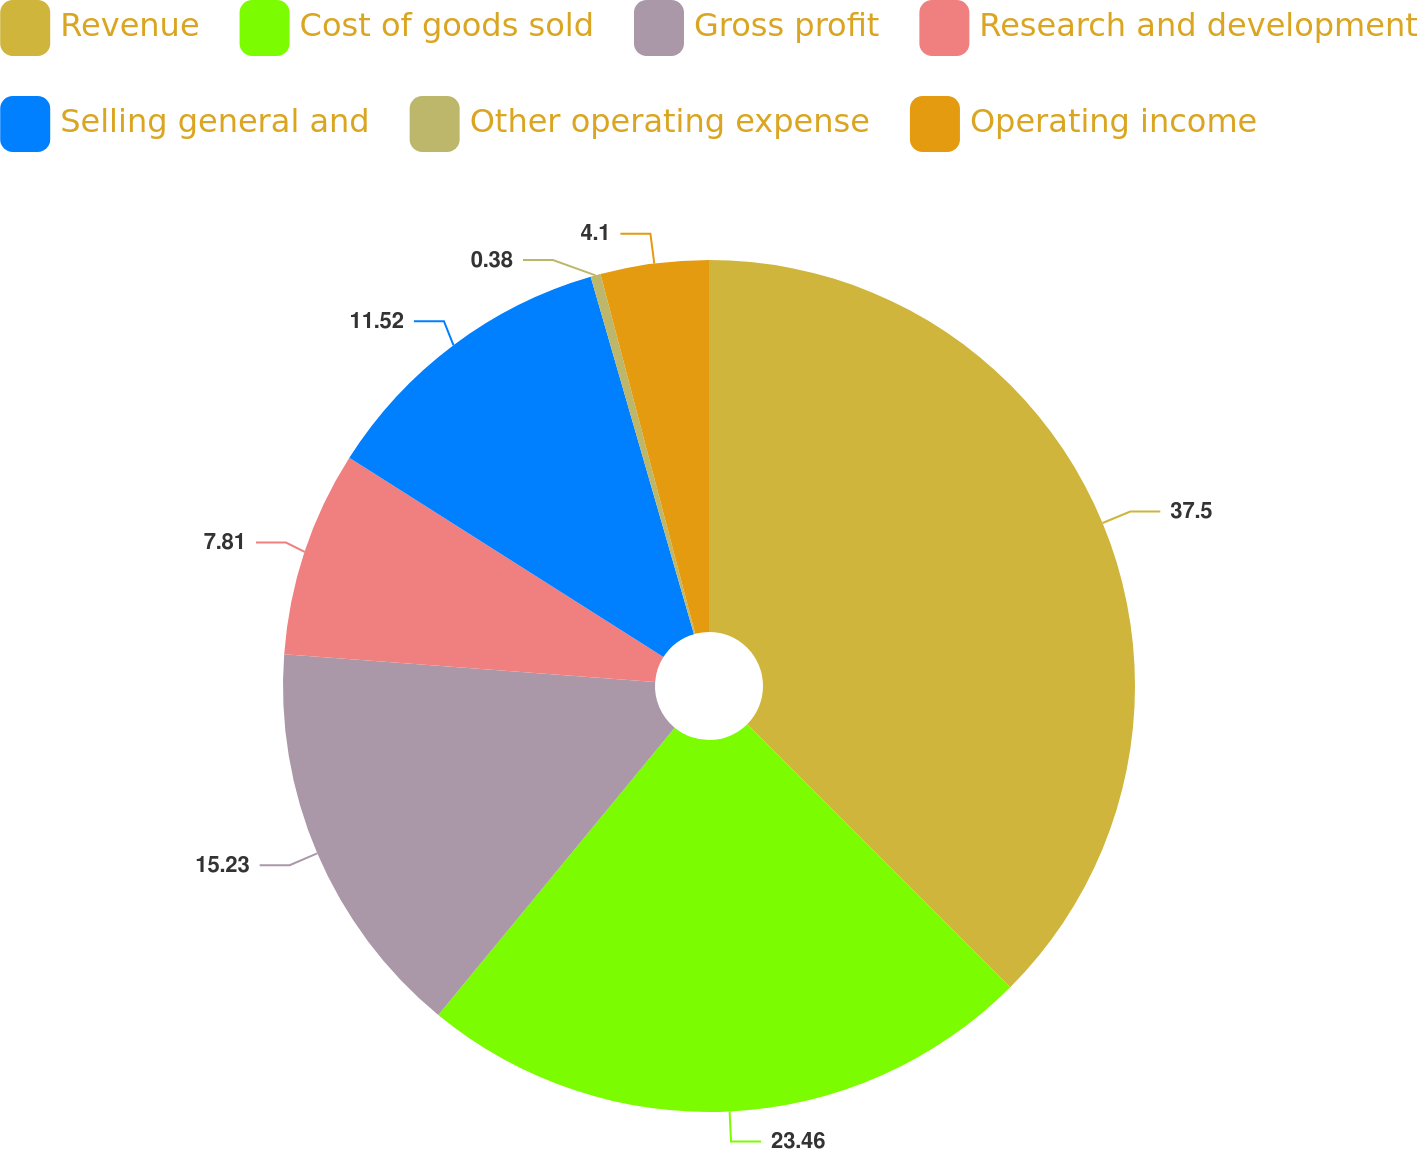Convert chart to OTSL. <chart><loc_0><loc_0><loc_500><loc_500><pie_chart><fcel>Revenue<fcel>Cost of goods sold<fcel>Gross profit<fcel>Research and development<fcel>Selling general and<fcel>Other operating expense<fcel>Operating income<nl><fcel>37.5%<fcel>23.46%<fcel>15.23%<fcel>7.81%<fcel>11.52%<fcel>0.38%<fcel>4.1%<nl></chart> 